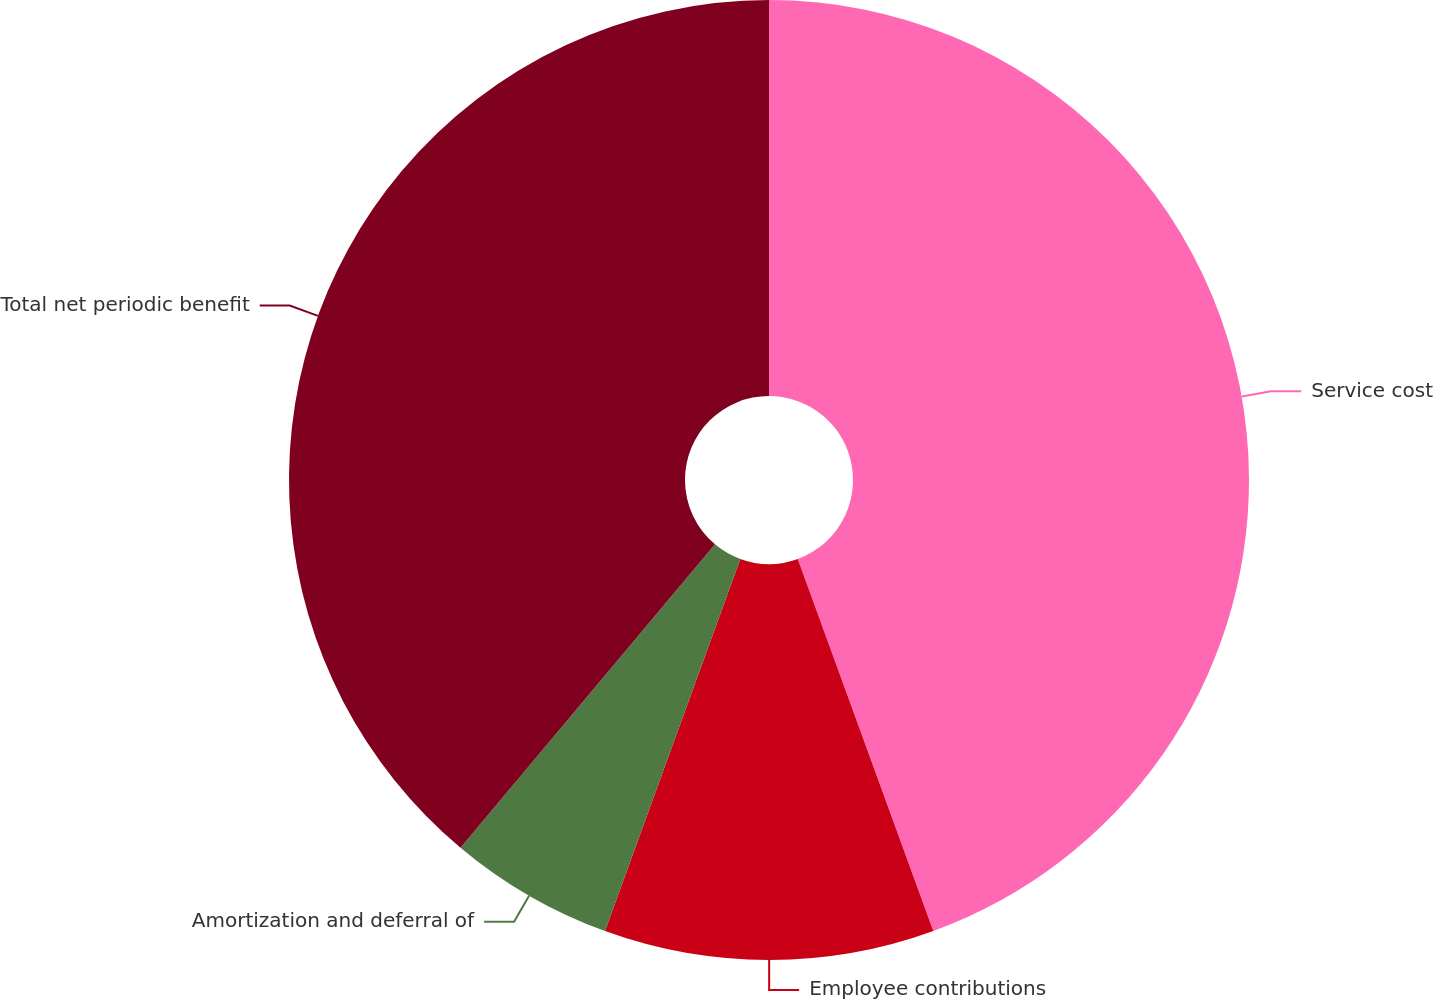Convert chart to OTSL. <chart><loc_0><loc_0><loc_500><loc_500><pie_chart><fcel>Service cost<fcel>Employee contributions<fcel>Amortization and deferral of<fcel>Total net periodic benefit<nl><fcel>44.44%<fcel>11.11%<fcel>5.56%<fcel>38.89%<nl></chart> 